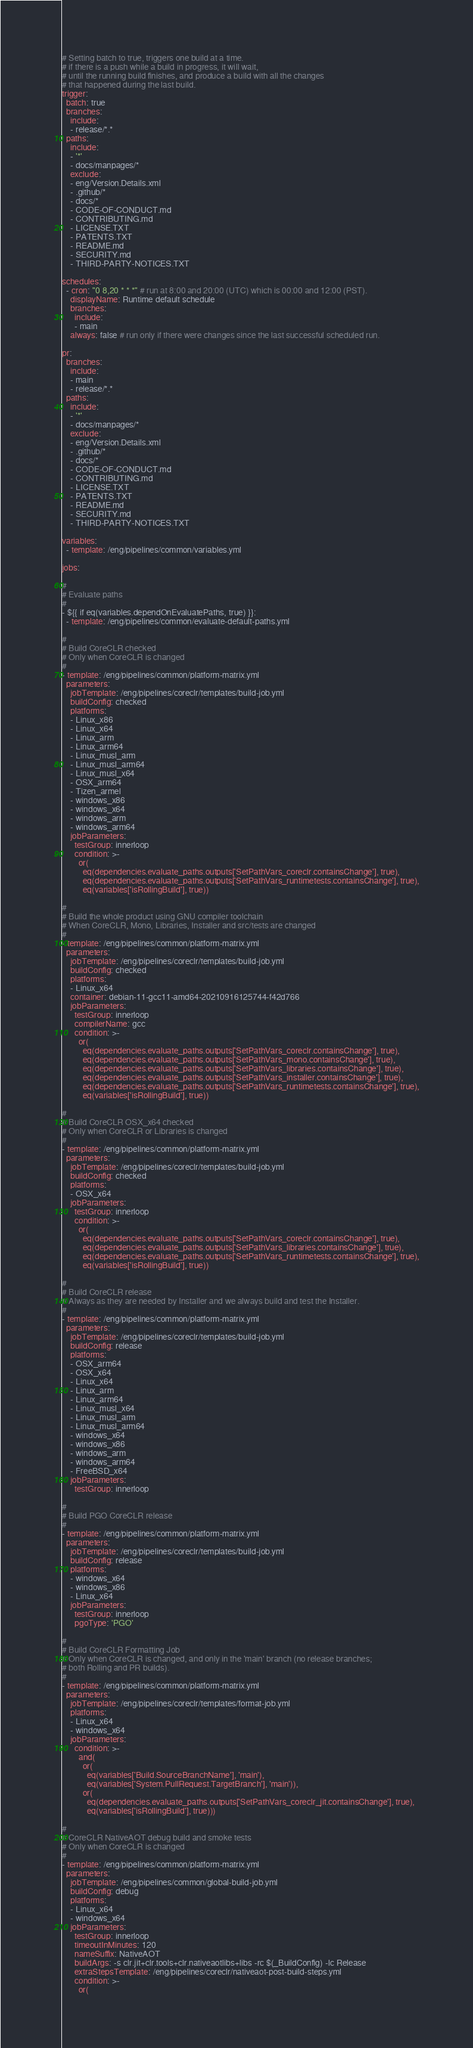<code> <loc_0><loc_0><loc_500><loc_500><_YAML_># Setting batch to true, triggers one build at a time.
# if there is a push while a build in progress, it will wait,
# until the running build finishes, and produce a build with all the changes
# that happened during the last build.
trigger:
  batch: true
  branches:
    include:
    - release/*.*
  paths:
    include:
    - '*'
    - docs/manpages/*
    exclude:
    - eng/Version.Details.xml
    - .github/*
    - docs/*
    - CODE-OF-CONDUCT.md
    - CONTRIBUTING.md
    - LICENSE.TXT
    - PATENTS.TXT
    - README.md
    - SECURITY.md
    - THIRD-PARTY-NOTICES.TXT

schedules:
  - cron: "0 8,20 * * *" # run at 8:00 and 20:00 (UTC) which is 00:00 and 12:00 (PST).
    displayName: Runtime default schedule
    branches:
      include:
      - main
    always: false # run only if there were changes since the last successful scheduled run.

pr:
  branches:
    include:
    - main
    - release/*.*
  paths:
    include:
    - '*'
    - docs/manpages/*
    exclude:
    - eng/Version.Details.xml
    - .github/*
    - docs/*
    - CODE-OF-CONDUCT.md
    - CONTRIBUTING.md
    - LICENSE.TXT
    - PATENTS.TXT
    - README.md
    - SECURITY.md
    - THIRD-PARTY-NOTICES.TXT

variables:
  - template: /eng/pipelines/common/variables.yml

jobs:

#
# Evaluate paths
#
- ${{ if eq(variables.dependOnEvaluatePaths, true) }}:
  - template: /eng/pipelines/common/evaluate-default-paths.yml

#
# Build CoreCLR checked
# Only when CoreCLR is changed
#
- template: /eng/pipelines/common/platform-matrix.yml
  parameters:
    jobTemplate: /eng/pipelines/coreclr/templates/build-job.yml
    buildConfig: checked
    platforms:
    - Linux_x86
    - Linux_x64
    - Linux_arm
    - Linux_arm64
    - Linux_musl_arm
    - Linux_musl_arm64
    - Linux_musl_x64
    - OSX_arm64
    - Tizen_armel
    - windows_x86
    - windows_x64
    - windows_arm
    - windows_arm64
    jobParameters:
      testGroup: innerloop
      condition: >-
        or(
          eq(dependencies.evaluate_paths.outputs['SetPathVars_coreclr.containsChange'], true),
          eq(dependencies.evaluate_paths.outputs['SetPathVars_runtimetests.containsChange'], true),
          eq(variables['isRollingBuild'], true))

#
# Build the whole product using GNU compiler toolchain
# When CoreCLR, Mono, Libraries, Installer and src/tests are changed
#
- template: /eng/pipelines/common/platform-matrix.yml
  parameters:
    jobTemplate: /eng/pipelines/coreclr/templates/build-job.yml
    buildConfig: checked
    platforms:
    - Linux_x64
    container: debian-11-gcc11-amd64-20210916125744-f42d766
    jobParameters:
      testGroup: innerloop
      compilerName: gcc
      condition: >-
        or(
          eq(dependencies.evaluate_paths.outputs['SetPathVars_coreclr.containsChange'], true),
          eq(dependencies.evaluate_paths.outputs['SetPathVars_mono.containsChange'], true),
          eq(dependencies.evaluate_paths.outputs['SetPathVars_libraries.containsChange'], true),
          eq(dependencies.evaluate_paths.outputs['SetPathVars_installer.containsChange'], true),
          eq(dependencies.evaluate_paths.outputs['SetPathVars_runtimetests.containsChange'], true),
          eq(variables['isRollingBuild'], true))

#
# Build CoreCLR OSX_x64 checked
# Only when CoreCLR or Libraries is changed
#
- template: /eng/pipelines/common/platform-matrix.yml
  parameters:
    jobTemplate: /eng/pipelines/coreclr/templates/build-job.yml
    buildConfig: checked
    platforms:
    - OSX_x64
    jobParameters:
      testGroup: innerloop
      condition: >-
        or(
          eq(dependencies.evaluate_paths.outputs['SetPathVars_coreclr.containsChange'], true),
          eq(dependencies.evaluate_paths.outputs['SetPathVars_libraries.containsChange'], true),
          eq(dependencies.evaluate_paths.outputs['SetPathVars_runtimetests.containsChange'], true),
          eq(variables['isRollingBuild'], true))

#
# Build CoreCLR release
# Always as they are needed by Installer and we always build and test the Installer.
#
- template: /eng/pipelines/common/platform-matrix.yml
  parameters:
    jobTemplate: /eng/pipelines/coreclr/templates/build-job.yml
    buildConfig: release
    platforms:
    - OSX_arm64
    - OSX_x64
    - Linux_x64
    - Linux_arm
    - Linux_arm64
    - Linux_musl_x64
    - Linux_musl_arm
    - Linux_musl_arm64
    - windows_x64
    - windows_x86
    - windows_arm
    - windows_arm64
    - FreeBSD_x64
    jobParameters:
      testGroup: innerloop

#
# Build PGO CoreCLR release
#
- template: /eng/pipelines/common/platform-matrix.yml
  parameters:
    jobTemplate: /eng/pipelines/coreclr/templates/build-job.yml
    buildConfig: release
    platforms:
    - windows_x64
    - windows_x86
    - Linux_x64
    jobParameters:
      testGroup: innerloop
      pgoType: 'PGO'

#
# Build CoreCLR Formatting Job
# Only when CoreCLR is changed, and only in the 'main' branch (no release branches;
# both Rolling and PR builds).
#
- template: /eng/pipelines/common/platform-matrix.yml
  parameters:
    jobTemplate: /eng/pipelines/coreclr/templates/format-job.yml
    platforms:
    - Linux_x64
    - windows_x64
    jobParameters:
      condition: >-
        and(
          or(
            eq(variables['Build.SourceBranchName'], 'main'),
            eq(variables['System.PullRequest.TargetBranch'], 'main')),
          or(
            eq(dependencies.evaluate_paths.outputs['SetPathVars_coreclr_jit.containsChange'], true),
            eq(variables['isRollingBuild'], true)))

#
# CoreCLR NativeAOT debug build and smoke tests
# Only when CoreCLR is changed
#
- template: /eng/pipelines/common/platform-matrix.yml
  parameters:
    jobTemplate: /eng/pipelines/common/global-build-job.yml
    buildConfig: debug
    platforms:
    - Linux_x64
    - windows_x64
    jobParameters:
      testGroup: innerloop
      timeoutInMinutes: 120
      nameSuffix: NativeAOT
      buildArgs: -s clr.jit+clr.tools+clr.nativeaotlibs+libs -rc $(_BuildConfig) -lc Release
      extraStepsTemplate: /eng/pipelines/coreclr/nativeaot-post-build-steps.yml
      condition: >-
        or(</code> 